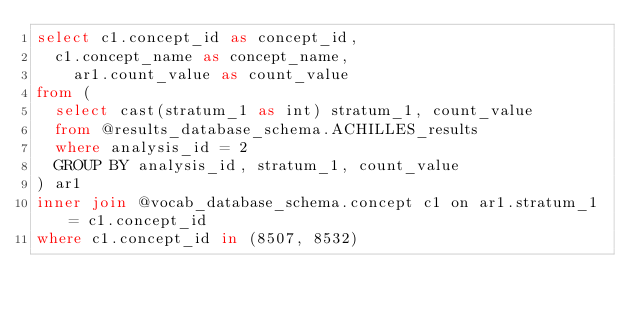Convert code to text. <code><loc_0><loc_0><loc_500><loc_500><_SQL_>select c1.concept_id as concept_id, 
  c1.concept_name as concept_name, 
	ar1.count_value as count_value
from (
  select cast(stratum_1 as int) stratum_1, count_value
  from @results_database_schema.ACHILLES_results
  where analysis_id = 2 
  GROUP BY analysis_id, stratum_1, count_value
) ar1 
inner join @vocab_database_schema.concept c1 on ar1.stratum_1 = c1.concept_id
where c1.concept_id in (8507, 8532)
</code> 